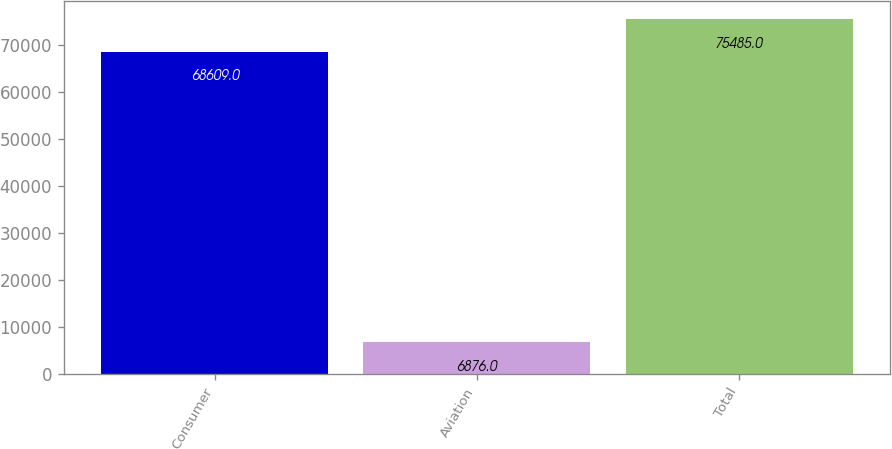Convert chart. <chart><loc_0><loc_0><loc_500><loc_500><bar_chart><fcel>Consumer<fcel>Aviation<fcel>Total<nl><fcel>68609<fcel>6876<fcel>75485<nl></chart> 